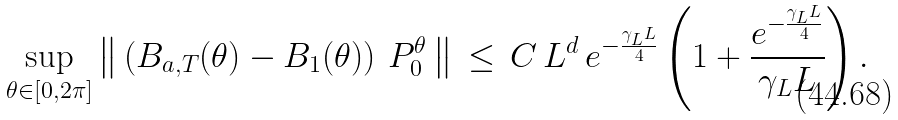<formula> <loc_0><loc_0><loc_500><loc_500>\sup _ { \theta \in [ 0 , 2 \pi ] } \left \| \, \left ( B _ { a , T } ( \theta ) - B _ { 1 } ( \theta ) \right ) \, P _ { 0 } ^ { \theta } \, \right \| \, \leq \, C \, L ^ { d } \, e ^ { - \frac { \gamma _ { L } L } { 4 } } \left ( 1 + \frac { e ^ { - \frac { \gamma _ { L } L } { 4 } } } { \gamma _ { L } L } \right ) .</formula> 